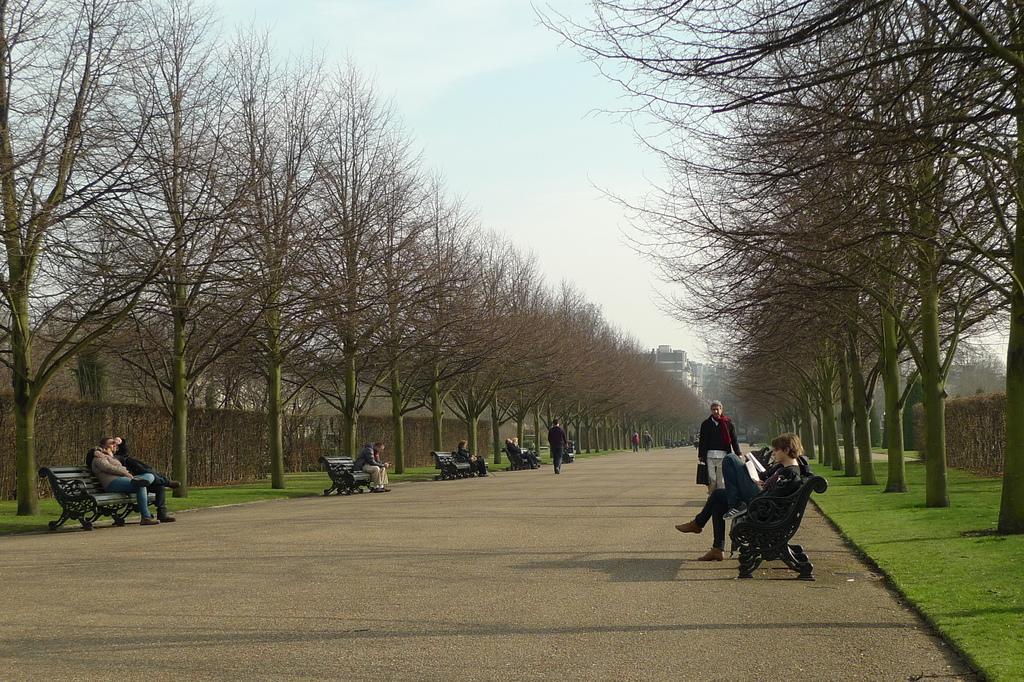Please provide a concise description of this image. In the image we can see the road, benches and on the benches there are people sitting and some of them are walking. Here we can see grass, trees, buildings and the sky. 